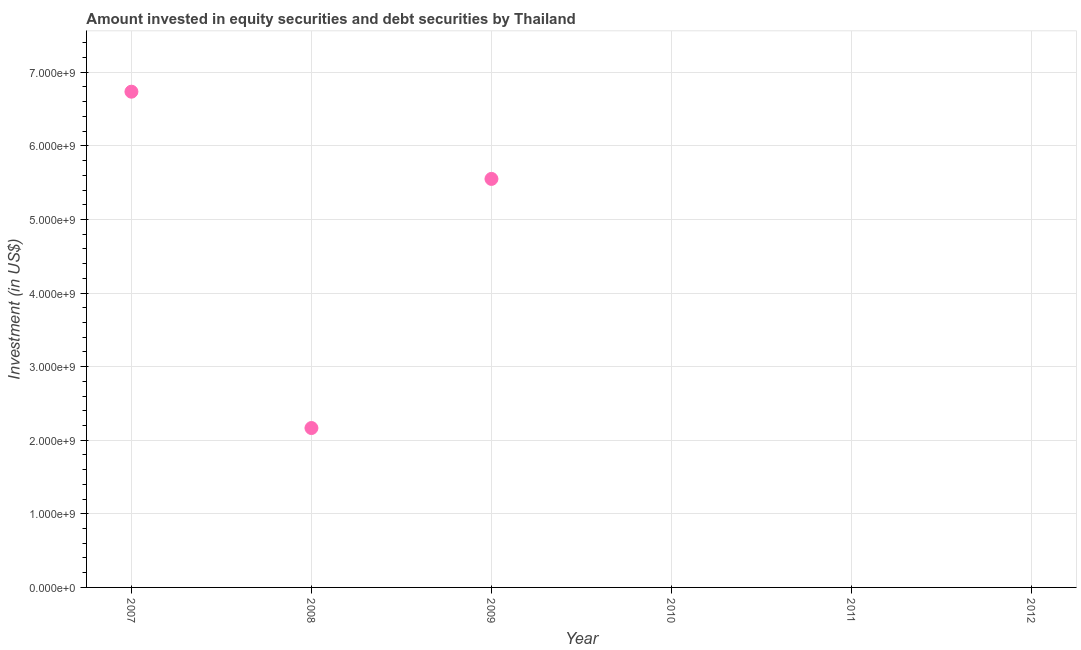Across all years, what is the maximum portfolio investment?
Your response must be concise. 6.74e+09. What is the sum of the portfolio investment?
Your answer should be compact. 1.45e+1. What is the difference between the portfolio investment in 2008 and 2009?
Your response must be concise. -3.39e+09. What is the average portfolio investment per year?
Your answer should be very brief. 2.41e+09. What is the median portfolio investment?
Provide a succinct answer. 1.08e+09. What is the ratio of the portfolio investment in 2007 to that in 2009?
Provide a succinct answer. 1.21. Is the portfolio investment in 2008 less than that in 2009?
Offer a terse response. Yes. Is the difference between the portfolio investment in 2007 and 2009 greater than the difference between any two years?
Provide a short and direct response. No. What is the difference between the highest and the second highest portfolio investment?
Keep it short and to the point. 1.19e+09. What is the difference between the highest and the lowest portfolio investment?
Your response must be concise. 6.74e+09. Are the values on the major ticks of Y-axis written in scientific E-notation?
Give a very brief answer. Yes. What is the title of the graph?
Provide a succinct answer. Amount invested in equity securities and debt securities by Thailand. What is the label or title of the Y-axis?
Provide a short and direct response. Investment (in US$). What is the Investment (in US$) in 2007?
Provide a short and direct response. 6.74e+09. What is the Investment (in US$) in 2008?
Offer a terse response. 2.17e+09. What is the Investment (in US$) in 2009?
Offer a very short reply. 5.55e+09. What is the Investment (in US$) in 2010?
Your answer should be compact. 0. What is the Investment (in US$) in 2011?
Provide a succinct answer. 0. What is the difference between the Investment (in US$) in 2007 and 2008?
Your response must be concise. 4.57e+09. What is the difference between the Investment (in US$) in 2007 and 2009?
Provide a short and direct response. 1.19e+09. What is the difference between the Investment (in US$) in 2008 and 2009?
Make the answer very short. -3.39e+09. What is the ratio of the Investment (in US$) in 2007 to that in 2008?
Offer a very short reply. 3.11. What is the ratio of the Investment (in US$) in 2007 to that in 2009?
Provide a short and direct response. 1.21. What is the ratio of the Investment (in US$) in 2008 to that in 2009?
Make the answer very short. 0.39. 